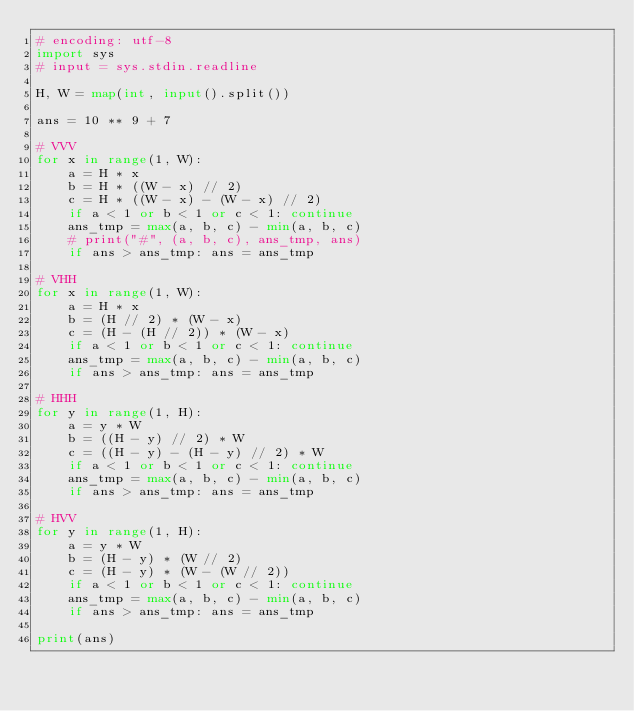Convert code to text. <code><loc_0><loc_0><loc_500><loc_500><_Python_># encoding: utf-8
import sys
# input = sys.stdin.readline

H, W = map(int, input().split())

ans = 10 ** 9 + 7

# VVV
for x in range(1, W):
    a = H * x
    b = H * ((W - x) // 2)
    c = H * ((W - x) - (W - x) // 2)
    if a < 1 or b < 1 or c < 1: continue
    ans_tmp = max(a, b, c) - min(a, b, c)
    # print("#", (a, b, c), ans_tmp, ans)
    if ans > ans_tmp: ans = ans_tmp

# VHH
for x in range(1, W):
    a = H * x
    b = (H // 2) * (W - x)
    c = (H - (H // 2)) * (W - x)
    if a < 1 or b < 1 or c < 1: continue
    ans_tmp = max(a, b, c) - min(a, b, c)
    if ans > ans_tmp: ans = ans_tmp

# HHH
for y in range(1, H):
    a = y * W
    b = ((H - y) // 2) * W
    c = ((H - y) - (H - y) // 2) * W
    if a < 1 or b < 1 or c < 1: continue
    ans_tmp = max(a, b, c) - min(a, b, c)
    if ans > ans_tmp: ans = ans_tmp

# HVV
for y in range(1, H):
    a = y * W
    b = (H - y) * (W // 2)
    c = (H - y) * (W - (W // 2))
    if a < 1 or b < 1 or c < 1: continue
    ans_tmp = max(a, b, c) - min(a, b, c)
    if ans > ans_tmp: ans = ans_tmp

print(ans)</code> 